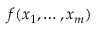Convert formula to latex. <formula><loc_0><loc_0><loc_500><loc_500>f ( x _ { 1 } , \dots , x _ { m } )</formula> 